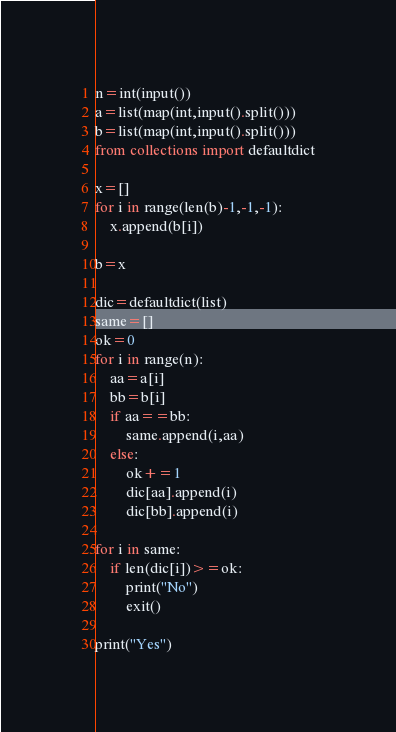Convert code to text. <code><loc_0><loc_0><loc_500><loc_500><_Python_>n=int(input())
a=list(map(int,input().split()))
b=list(map(int,input().split()))
from collections import defaultdict

x=[]
for i in range(len(b)-1,-1,-1):
    x.append(b[i])
    
b=x

dic=defaultdict(list)
same=[]
ok=0
for i in range(n):
    aa=a[i]
    bb=b[i]
    if aa==bb:
        same.append(i,aa)
    else:
        ok+=1
        dic[aa].append(i)
        dic[bb].append(i)

for i in same:
    if len(dic[i])>=ok:
        print("No")
        exit()
        
print("Yes")</code> 